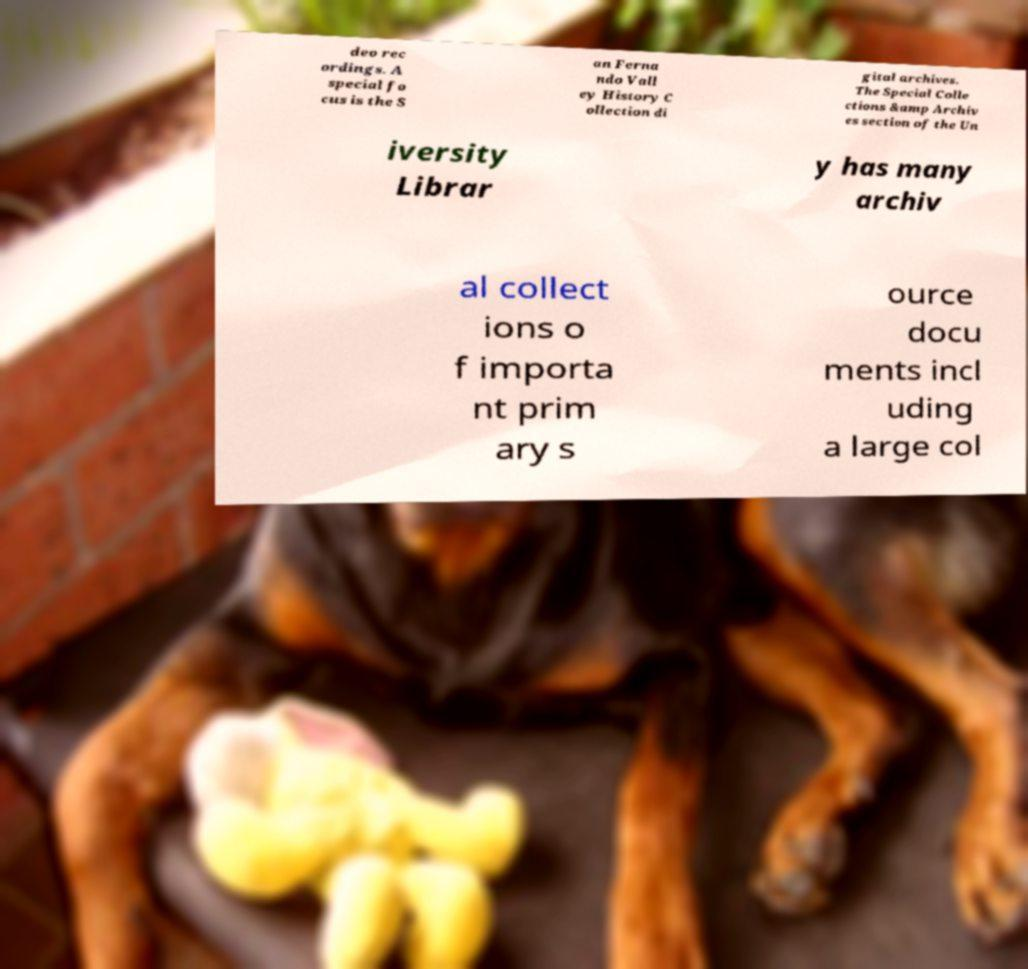Could you extract and type out the text from this image? deo rec ordings. A special fo cus is the S an Ferna ndo Vall ey History C ollection di gital archives. The Special Colle ctions &amp Archiv es section of the Un iversity Librar y has many archiv al collect ions o f importa nt prim ary s ource docu ments incl uding a large col 